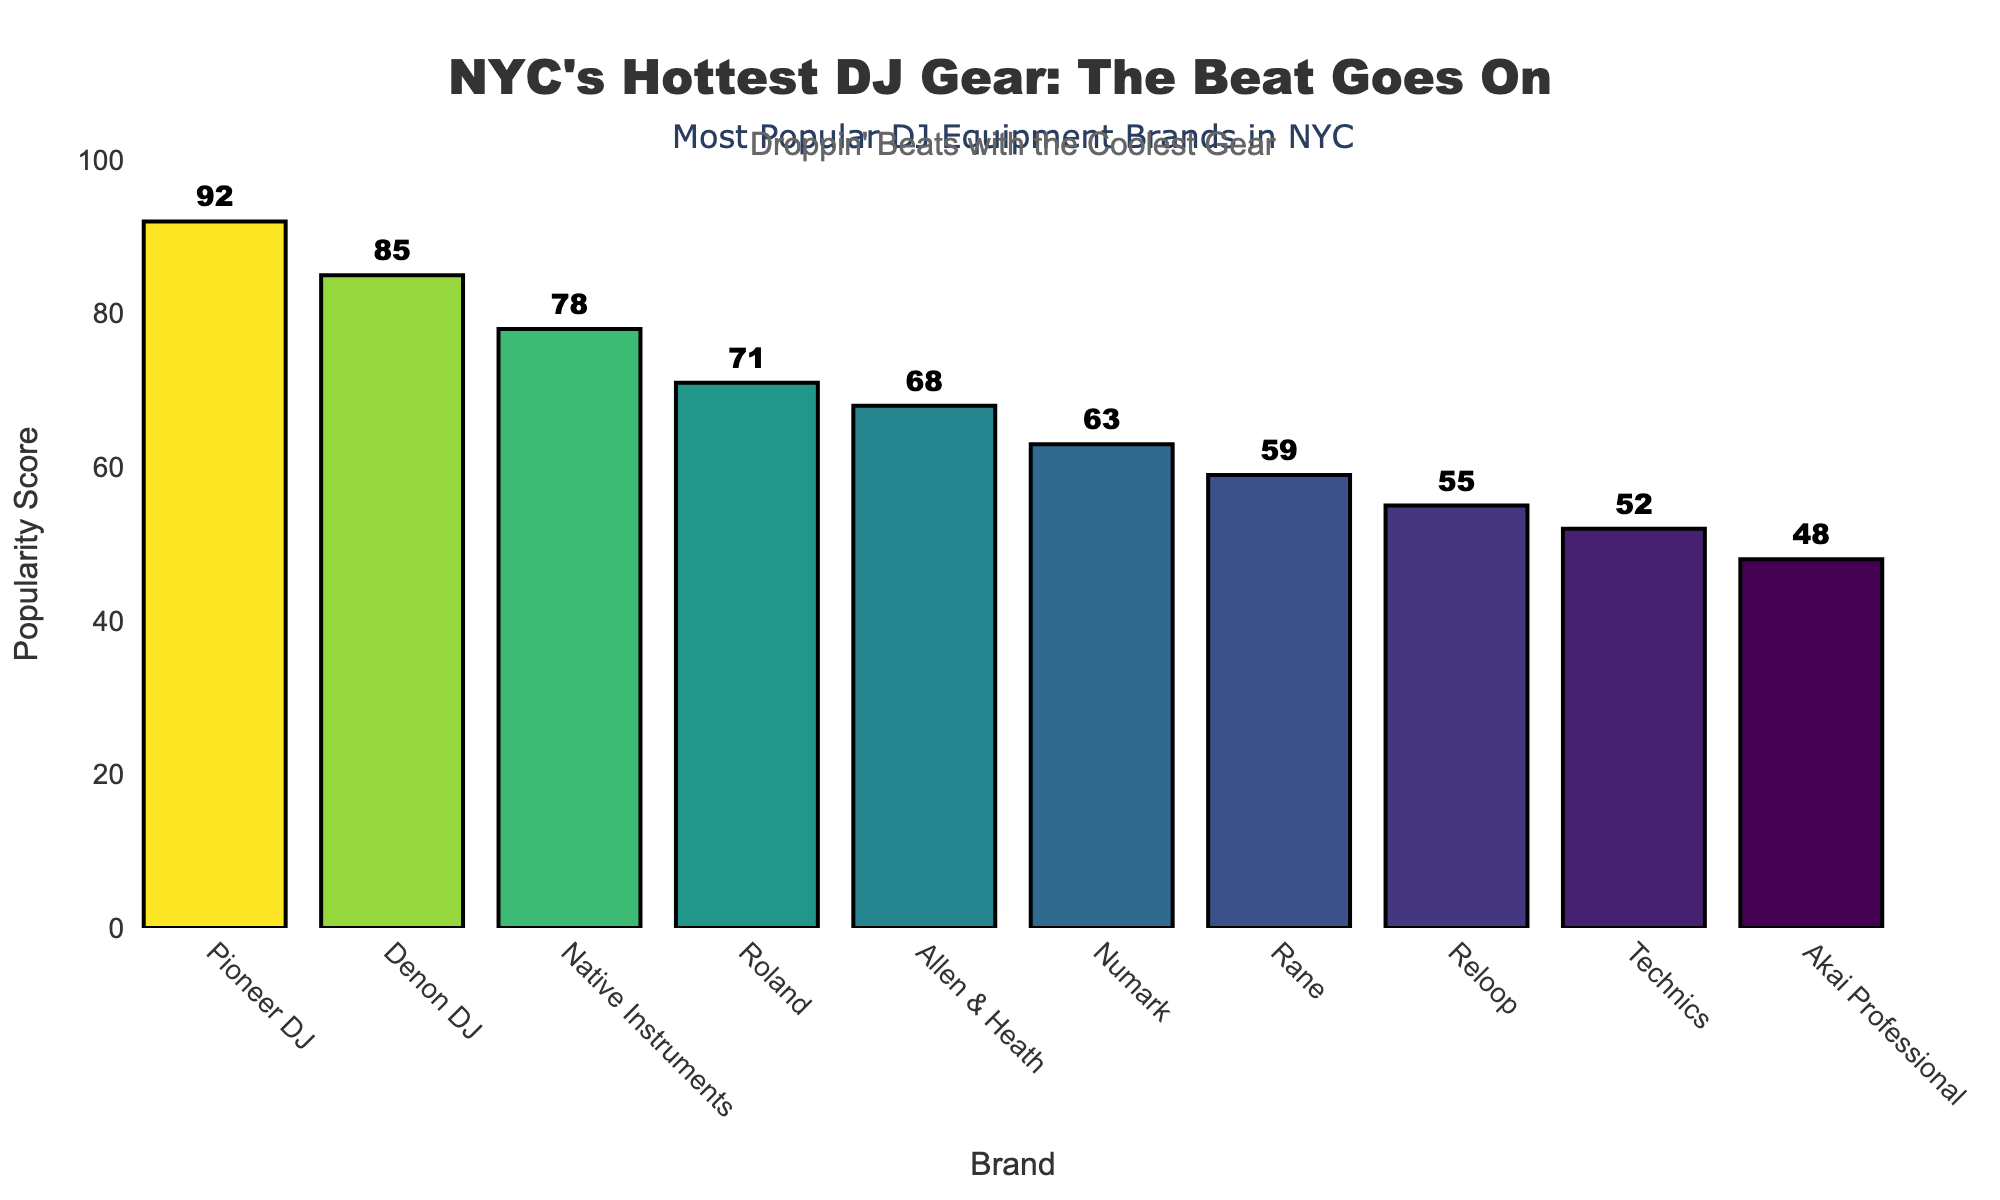What is the most popular DJ equipment brand among NYC club DJs? The height of the bars indicates popularity score. "Pioneer DJ" has the tallest bar, suggesting it has the highest popularity score.
Answer: Pioneer DJ Which two brands have a popularity score difference of 7? By comparing the popularity scores, "Pioneer DJ" (92) and "Denon DJ" (85) have a difference of 92 - 85 = 7.
Answer: Pioneer DJ and Denon DJ What is the total popularity score for Denon DJ and Native Instruments combined? Denon DJ has a popularity score of 85 and Native Instruments has a score of 78. Adding these together, we get 85 + 78 = 163.
Answer: 163 Which brand is less popular: Rane or Reloop? By comparing the heights of the bars, "Rane" (59) has a shorter bar than "Reloop" (55), indicating it is less popular.
Answer: Rane What is the average popularity score of all brands listed? Summing all popularity scores: 92 + 85 + 78 + 71 + 68 + 63 + 59 + 55 + 52 + 48 = 671. There are 10 brands. So, the average is 671 / 10 = 67.1.
Answer: 67.1 Which brand has a popularity score closest to 60? The popularity scores close to 60 are for "Rane" (59) and "Numark" (63). "Rane" with a score of 59 is the closest to 60.
Answer: Rane How much more popular is Pioneer DJ compared to Technics? Pioneer DJ has a score of 92, and Technics has a score of 52. The difference is 92 - 52 = 40.
Answer: 40 Which brand appears to be the least popular among NYC club DJs? The shortest bar represents the lowest popularity score. "Akai Professional" with a score of 48 has the shortest bar.
Answer: Akai Professional What is the second most popular DJ equipment brand? The brand with the second tallest bar is "Denon DJ" with a score of 85, making it the second most popular.
Answer: Denon DJ 